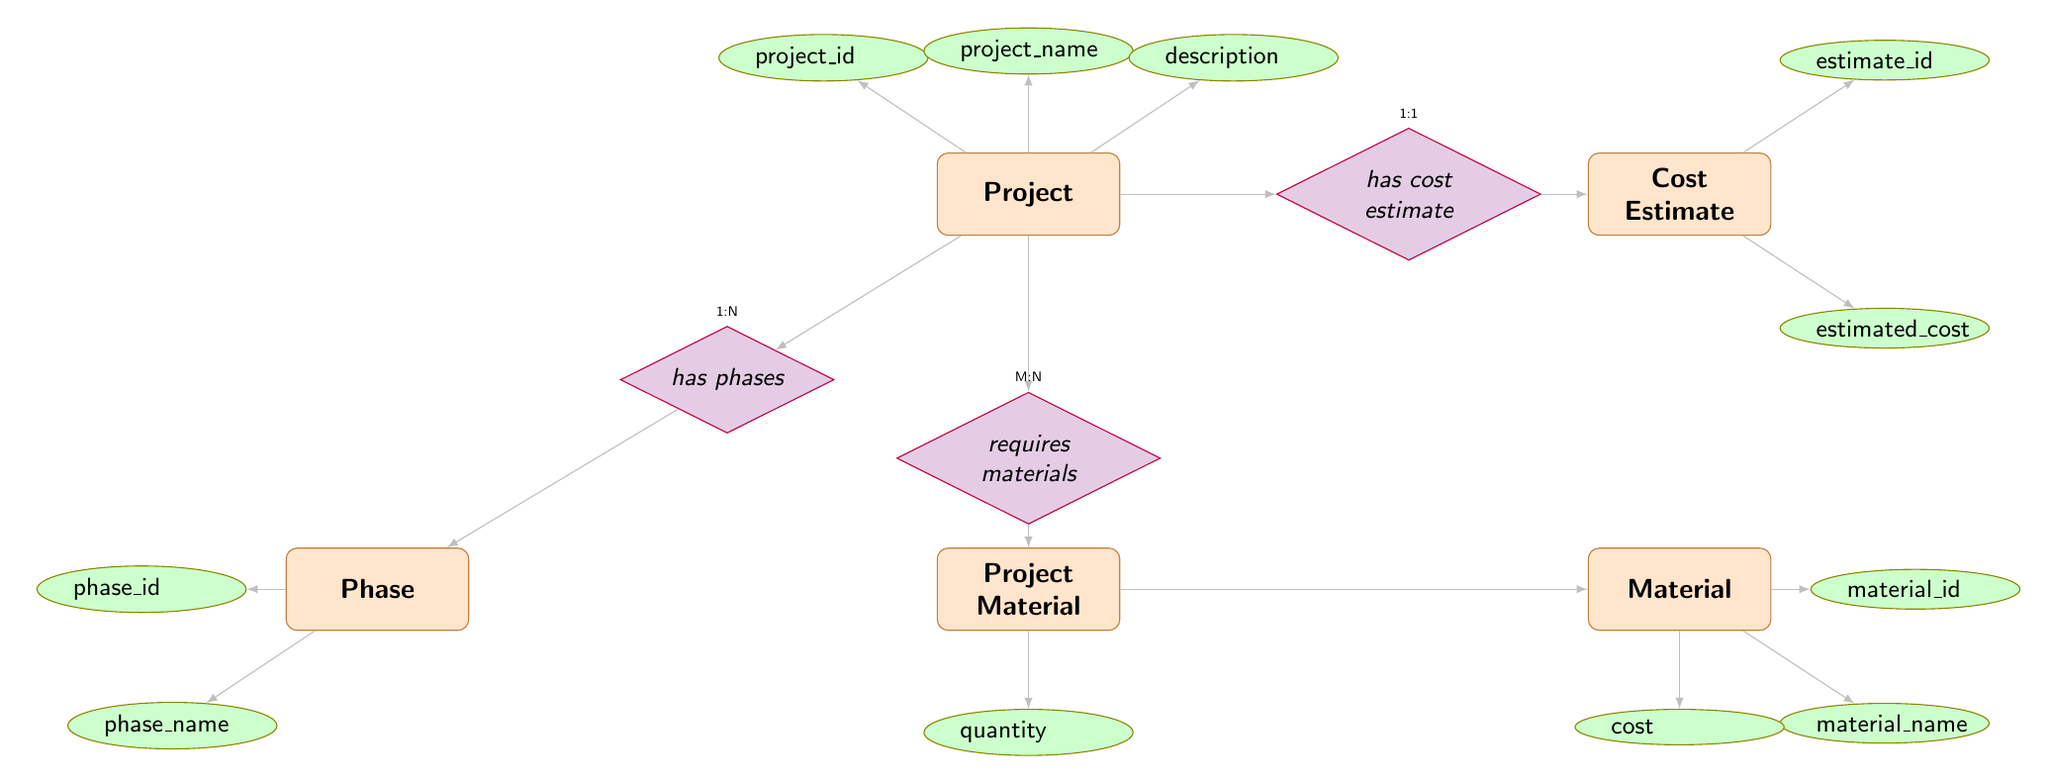What are the entities in this diagram? The diagram includes five entities: Project, Phase, Material, Project Material, and Cost Estimate. This can be identified by looking at the labeled rectangles on the diagram.
Answer: Project, Phase, Material, Project Material, Cost Estimate How many attributes does the 'Project' entity have? The 'Project' entity has three attributes: project_id, project_name, and description. This is determined by the connecting ellipses linked to the 'Project' rectangle.
Answer: 3 What is the relationship name between 'Project' and 'Phase'? The relationship name is 'has phases', which can be found in the diamond connecting the 'Project' and 'Phase' entities.
Answer: has phases What is the cardinality of the relationship between 'Project' and 'Cost Estimate'? The cardinality is 1 to 1, indicated by the tiny labels above the relationship connecting 'Project' and 'Cost Estimate'.
Answer: 1:1 Which entity requires materials? The 'Project' entity requires materials, as seen in the relationship labeled 'requires materials' connecting 'Project' and 'Project Material'.
Answer: Project How many phases can a single project have? A single project can have many phases, as indicated by the '1 to many' cardinality next to the relationship 'has phases'.
Answer: Many What is the connection type between 'Material' and 'Project Material'? The connection type is many to many, as indicated by the cardinality marking next to the relationship between 'Requires Materials' and the 'Project Material' entity.
Answer: Many to many What is the cost of a material? The 'Material' entity has an attribute named 'cost', which represents the cost of that material as defined within its attributes.
Answer: cost What attribute is linked to 'ProjectMaterial'? The linked attribute is 'quantity', which is specified in the 'Project Material' entity and describes the number of materials required for the project.
Answer: quantity 